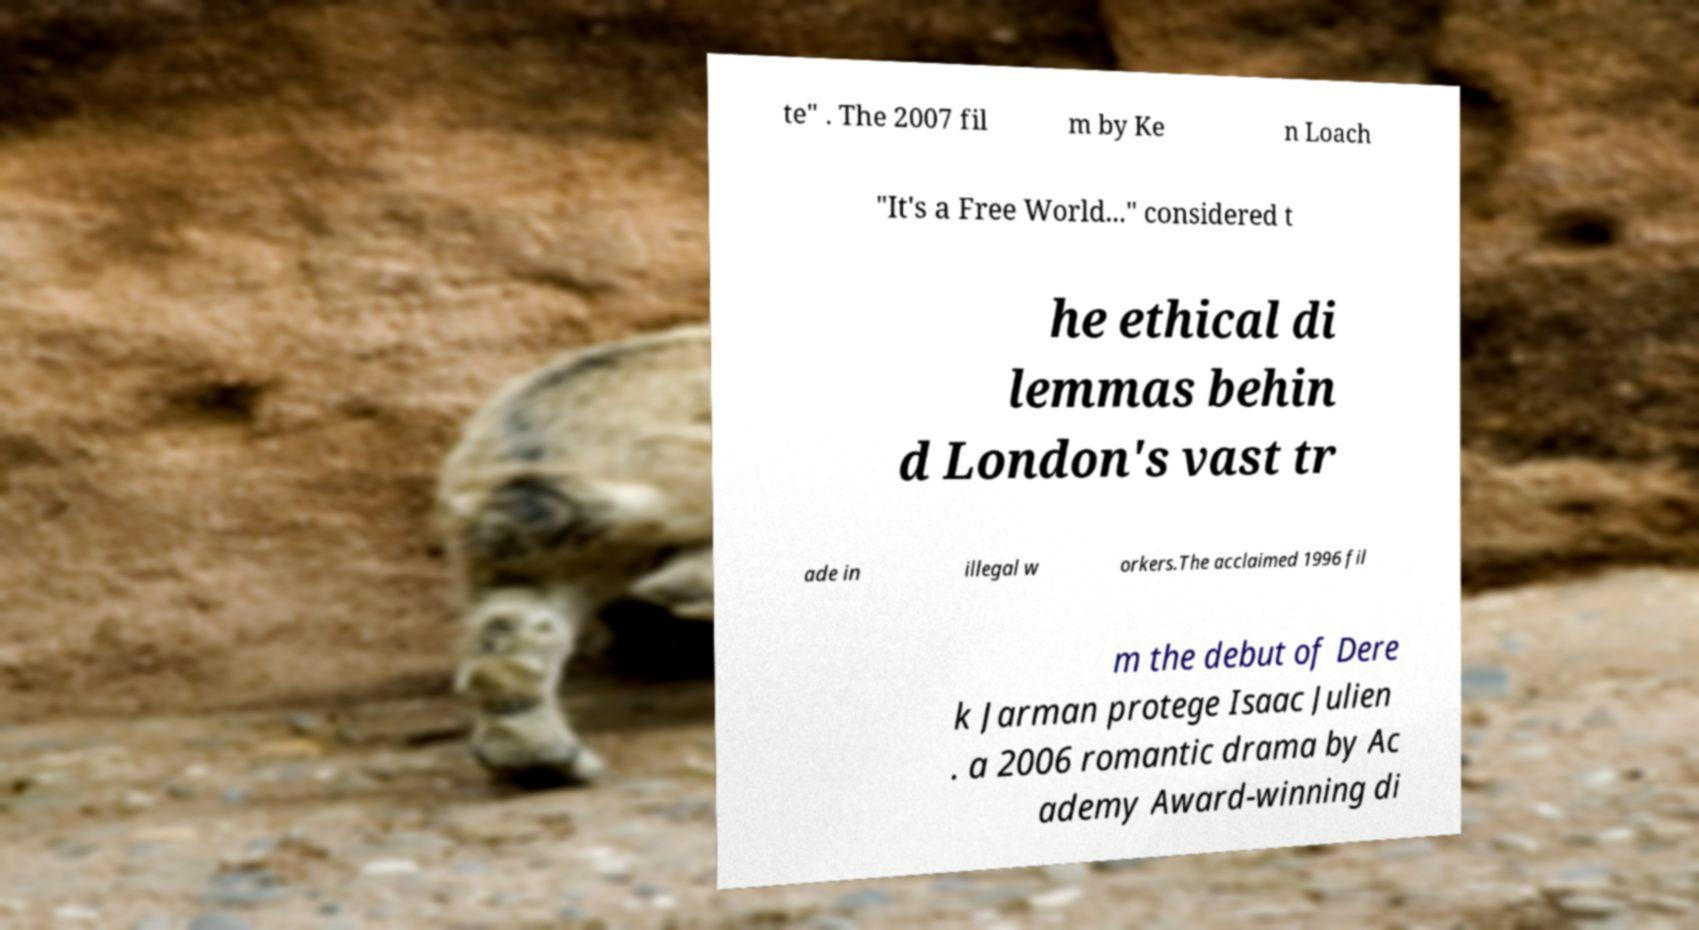Could you extract and type out the text from this image? te" . The 2007 fil m by Ke n Loach "It's a Free World..." considered t he ethical di lemmas behin d London's vast tr ade in illegal w orkers.The acclaimed 1996 fil m the debut of Dere k Jarman protege Isaac Julien . a 2006 romantic drama by Ac ademy Award-winning di 